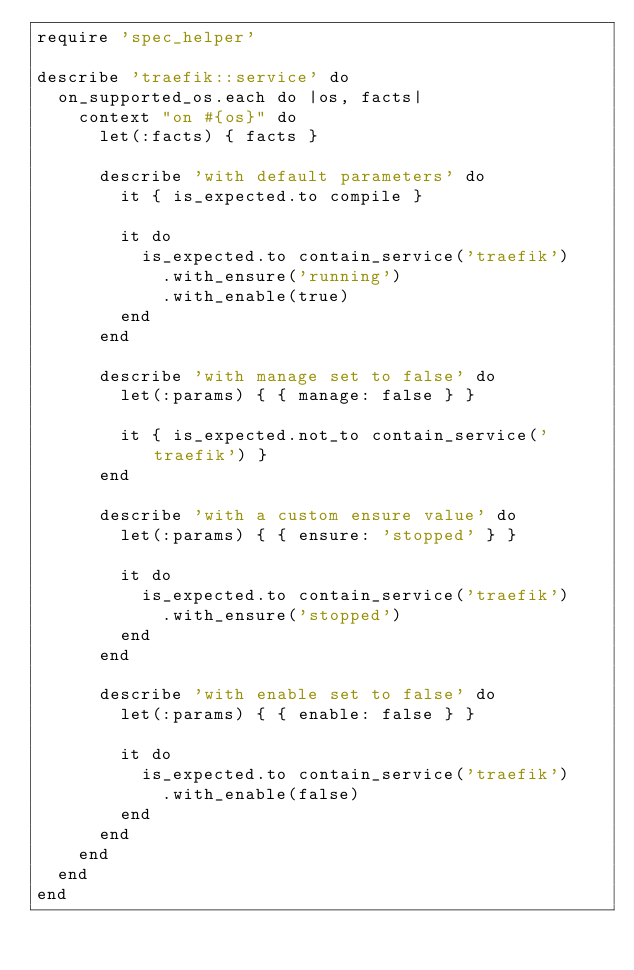Convert code to text. <code><loc_0><loc_0><loc_500><loc_500><_Ruby_>require 'spec_helper'

describe 'traefik::service' do
  on_supported_os.each do |os, facts|
    context "on #{os}" do
      let(:facts) { facts }

      describe 'with default parameters' do
        it { is_expected.to compile }

        it do
          is_expected.to contain_service('traefik')
            .with_ensure('running')
            .with_enable(true)
        end
      end

      describe 'with manage set to false' do
        let(:params) { { manage: false } }

        it { is_expected.not_to contain_service('traefik') }
      end

      describe 'with a custom ensure value' do
        let(:params) { { ensure: 'stopped' } }

        it do
          is_expected.to contain_service('traefik')
            .with_ensure('stopped')
        end
      end

      describe 'with enable set to false' do
        let(:params) { { enable: false } }

        it do
          is_expected.to contain_service('traefik')
            .with_enable(false)
        end
      end
    end
  end
end
</code> 